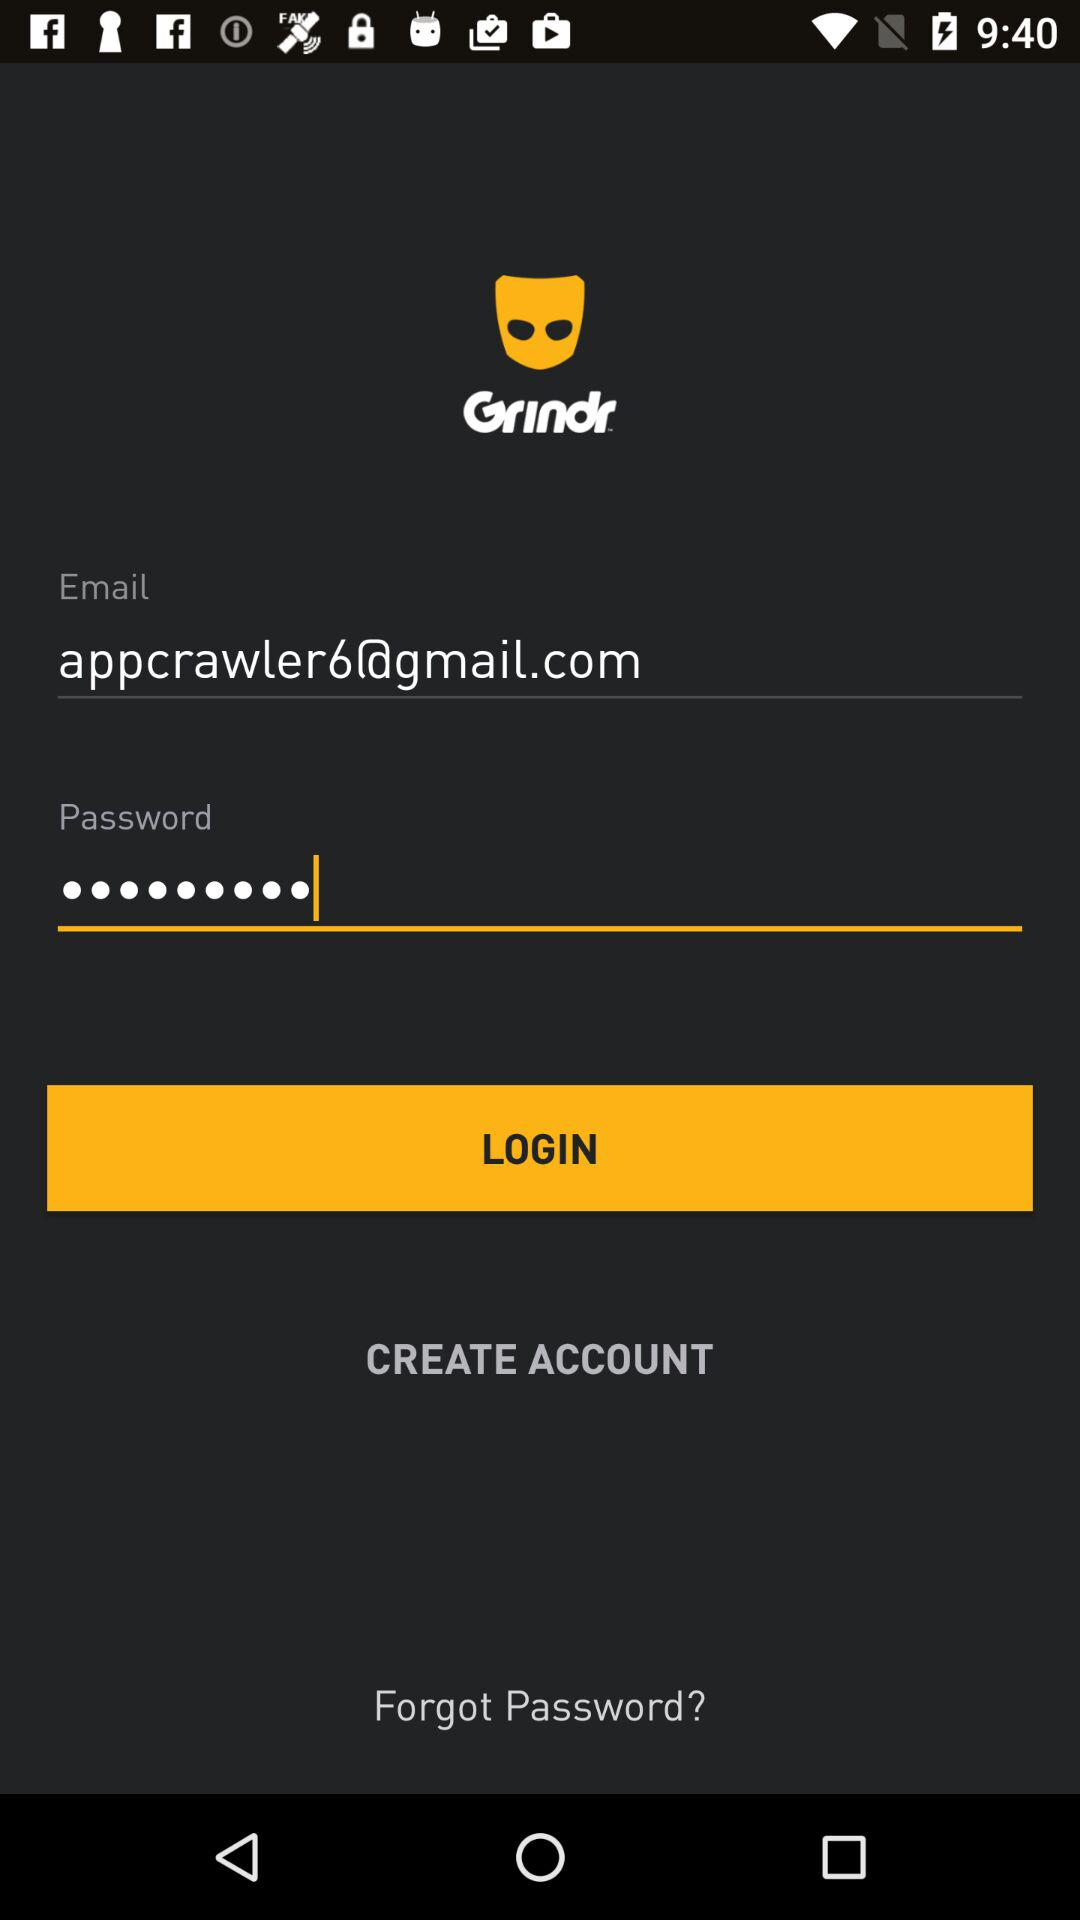What is the email address? The email address is appcrawler6@gmail.com. 